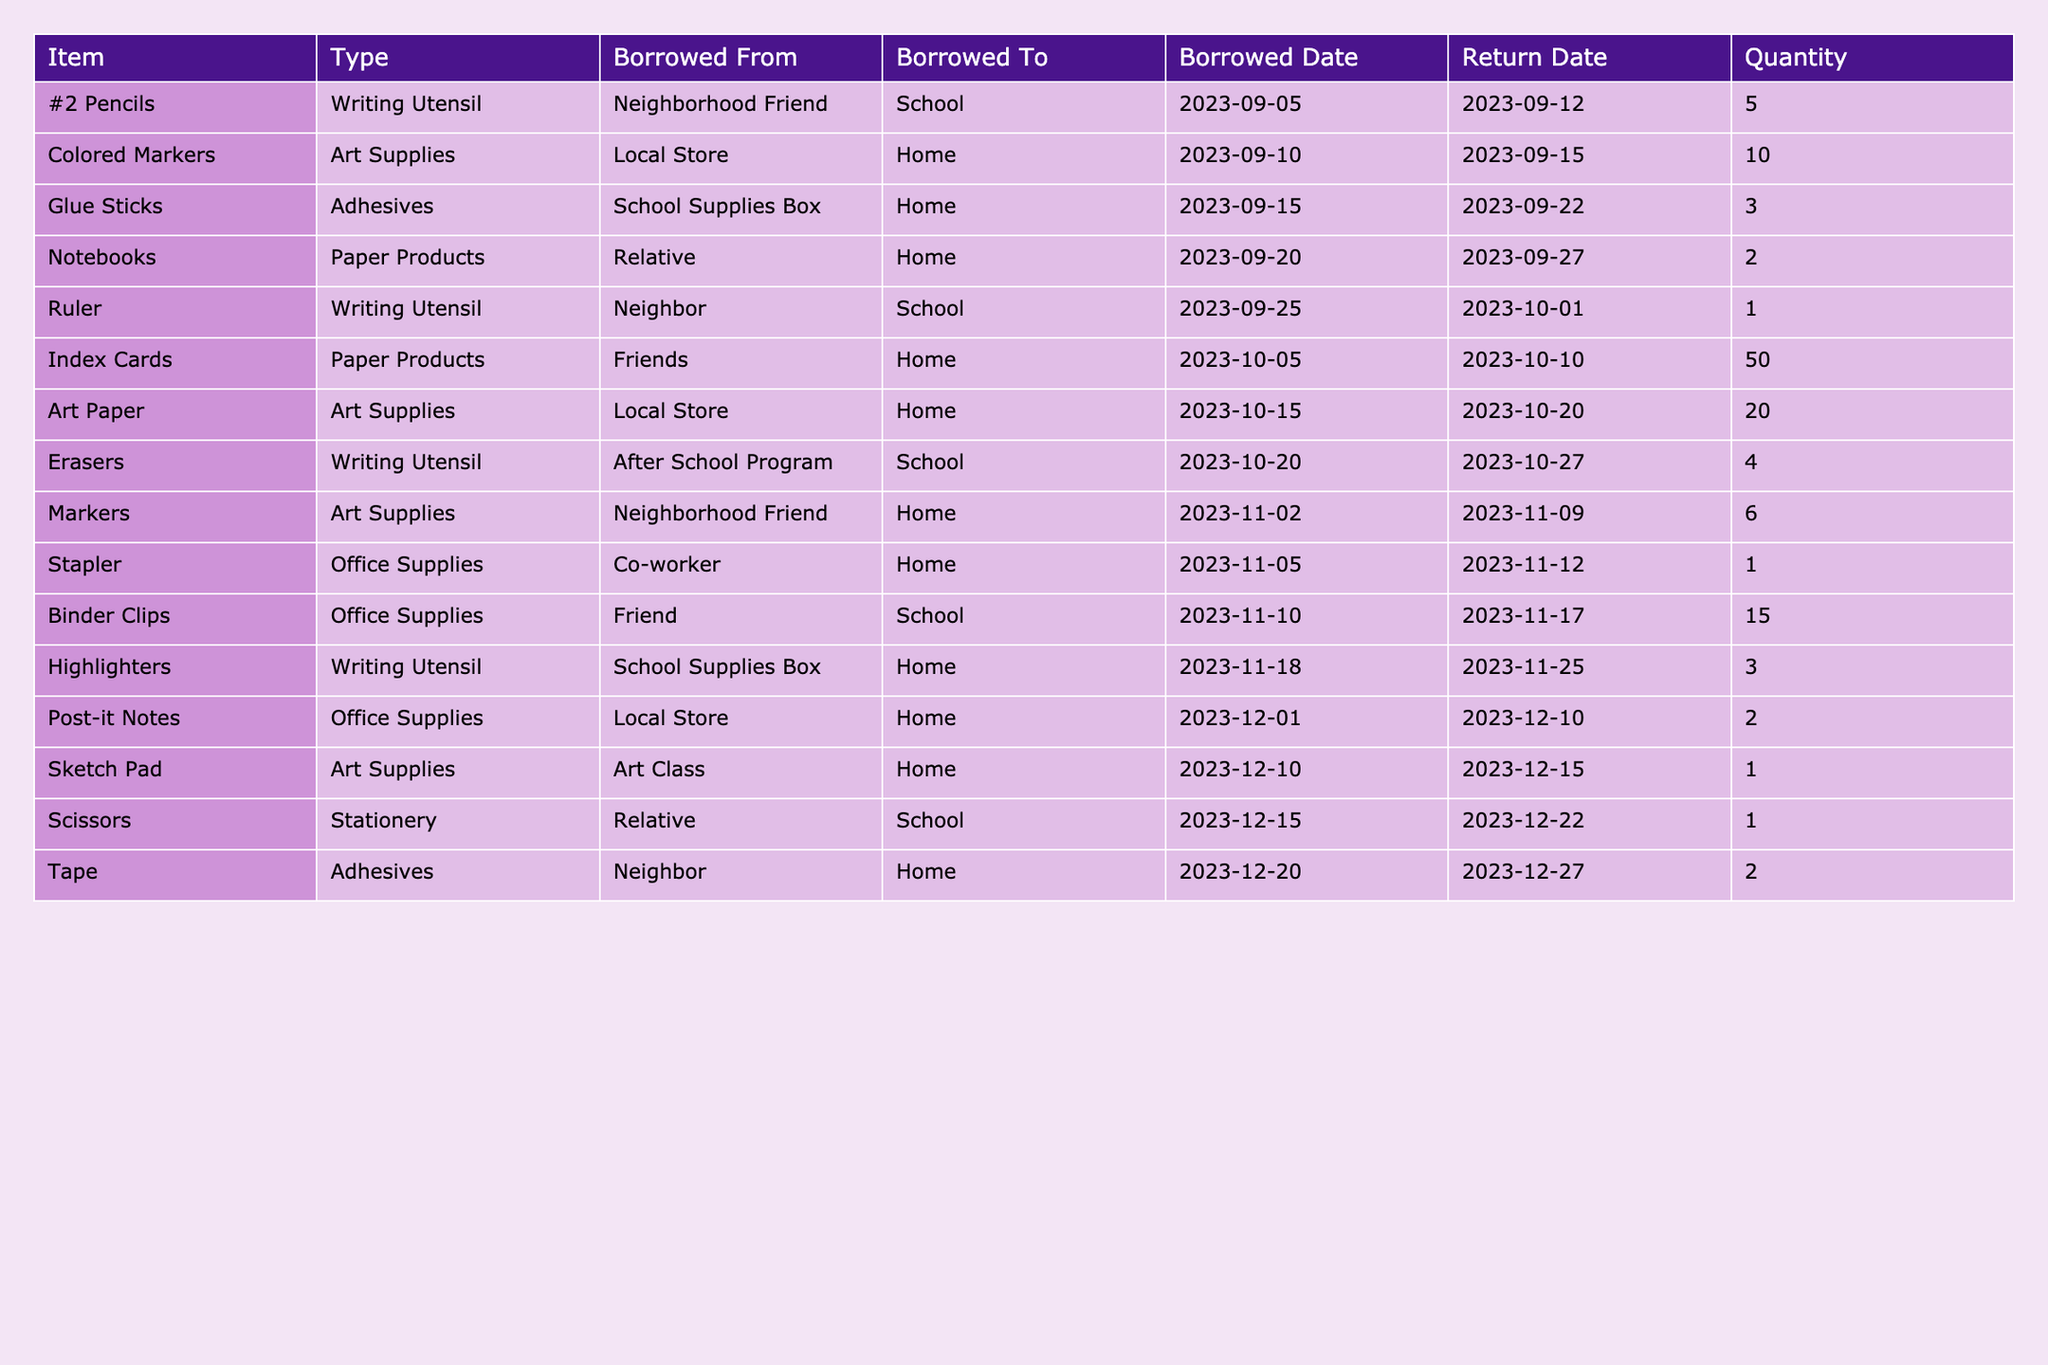What is the total quantity of colored markers borrowed? There is one entry for colored markers in the table, indicating a quantity of 10.
Answer: 10 How many glue sticks were borrowed? There is one row in the table that talks about glue sticks, listing a quantity of 3.
Answer: 3 Did I borrow any rulers? The table shows an entry for rulers with a borrowed quantity of 1, indicating that rulers were borrowed.
Answer: Yes What's the total quantity of erasers and highlighters borrowed combined? The table contains 4 erasers and 3 highlighters. Adding these gives a total of 4 + 3 = 7.
Answer: 7 Which item was borrowed the most in terms of quantity? The index cards have the highest quantity listed in the table, with a total of 50 borrowed.
Answer: Index Cards How many different types of art supplies were borrowed? The table lists two types of art supplies, which are colored markers and art paper.
Answer: 2 What is the average quantity of items borrowed from neighbors? The table shows 1 ruler (from a neighbor) and 2 rolls of tape (also from a neighbor). The average is (1 + 2) / 2 = 1.5.
Answer: 1.5 Was there any item that was borrowed from the local store? Yes, both colored markers and art paper were borrowed from the local store.
Answer: Yes How many items were borrowed that needed to be returned in December? The table lists three items with return dates in December: post-it notes, sketch pad, and tape.
Answer: 3 